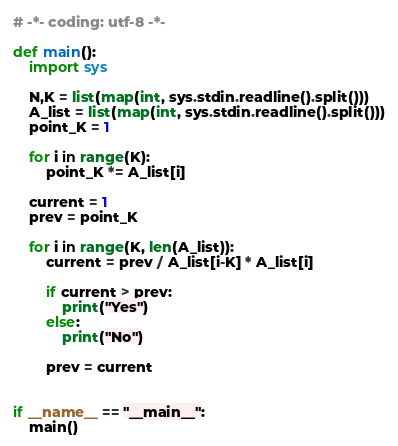Convert code to text. <code><loc_0><loc_0><loc_500><loc_500><_Python_># -*- coding: utf-8 -*-

def main():
    import sys

    N,K = list(map(int, sys.stdin.readline().split()))
    A_list = list(map(int, sys.stdin.readline().split()))
    point_K = 1
    
    for i in range(K):
        point_K *= A_list[i]
    
    current = 1
    prev = point_K

    for i in range(K, len(A_list)):
        current = prev / A_list[i-K] * A_list[i]

        if current > prev:
            print("Yes")
        else:
            print("No")
        
        prev = current


if __name__ == "__main__":
    main()
</code> 